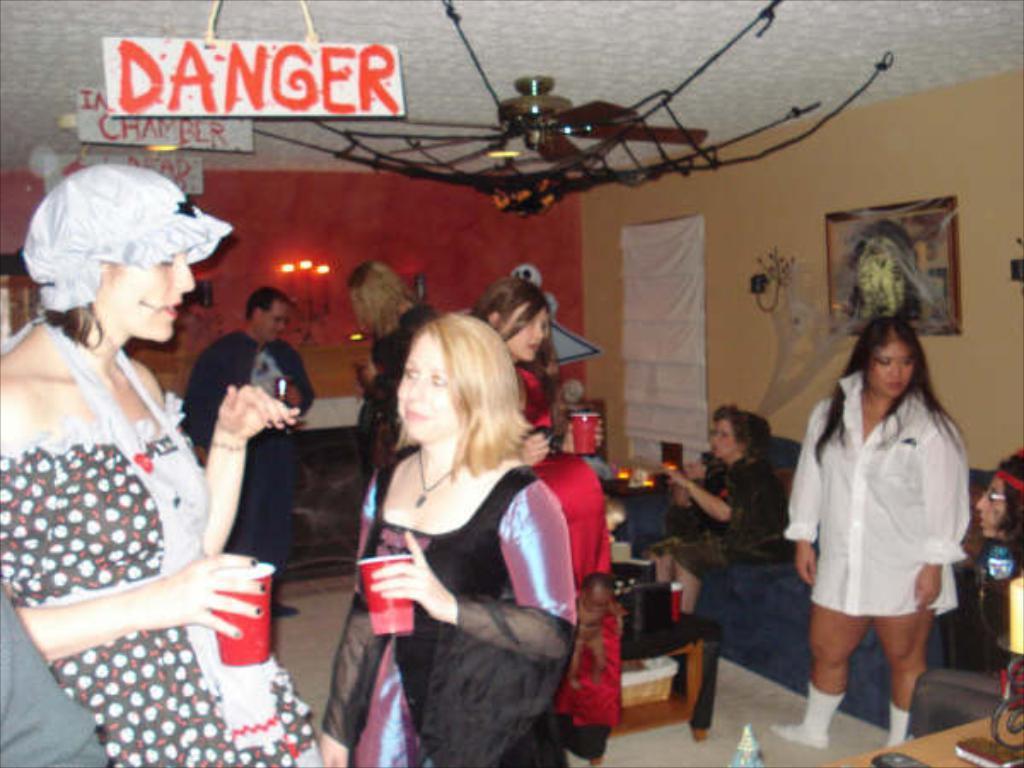Describe this image in one or two sentences. In this image there are few people standing and few are sitting on sofa holding cups in there hands, in the background there is a wall, on that wall there are frames lights, on the top there is ceiling and a fan and there are boards , on that boards some text is written. 